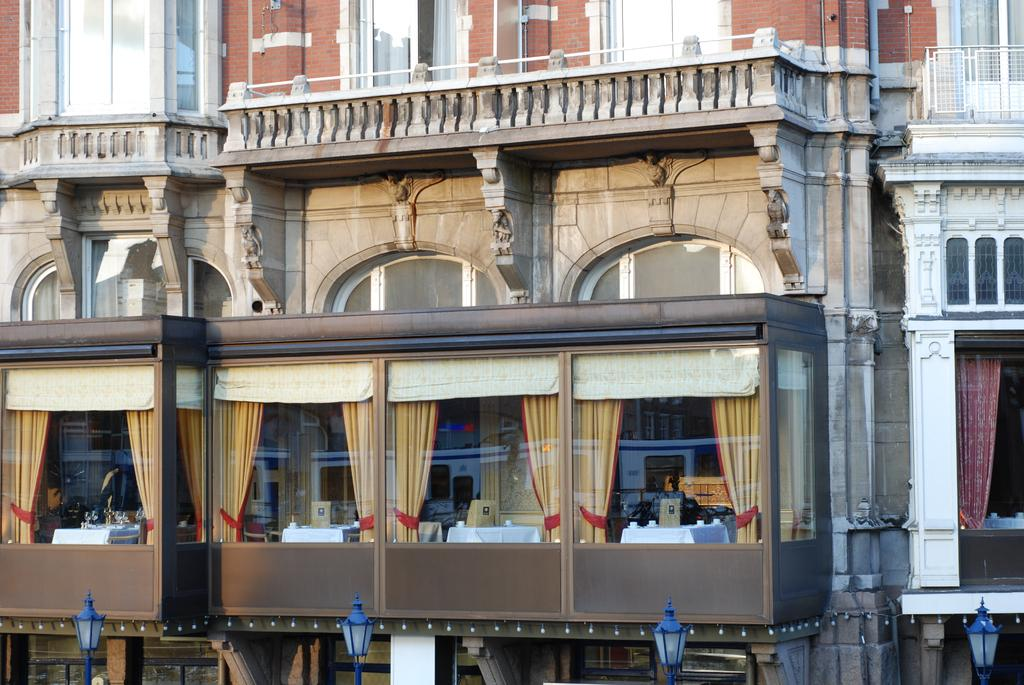What type of structures can be seen in the image? There are buildings in the image. What features do the buildings have? The buildings have glass windows and railings. What can be seen through the glass windows? Curtains are visible through the glass windows. What type of objects are present in large numbers in the image? There are many tables in the image. What type of bait is being used to catch fish in the image? There is no fishing or bait present in the image. Can you see a ladybug on any of the tables in the image? There is no ladybug present in the image. 